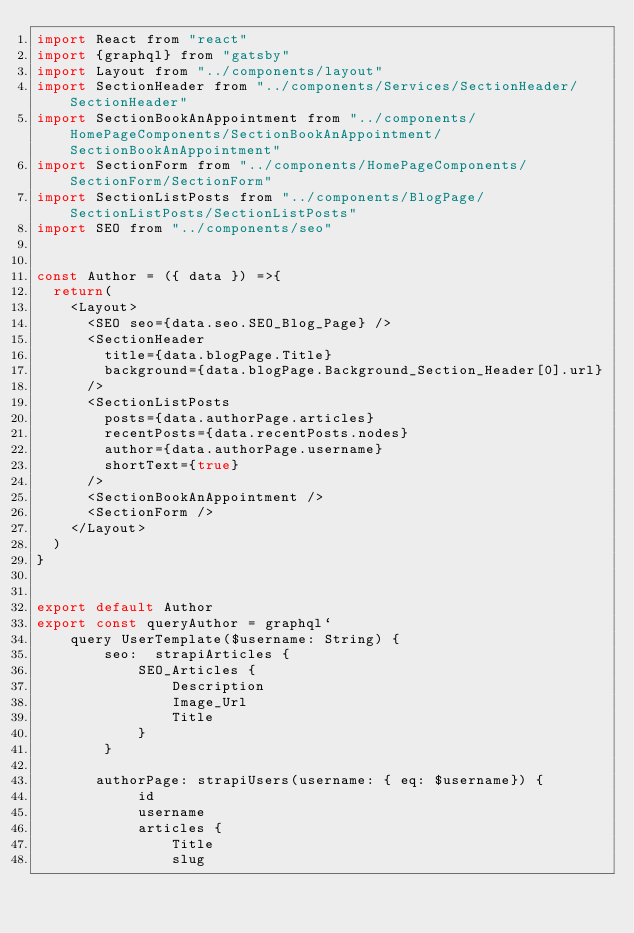<code> <loc_0><loc_0><loc_500><loc_500><_JavaScript_>import React from "react"
import {graphql} from "gatsby"
import Layout from "../components/layout"
import SectionHeader from "../components/Services/SectionHeader/SectionHeader"
import SectionBookAnAppointment from "../components/HomePageComponents/SectionBookAnAppointment/SectionBookAnAppointment"
import SectionForm from "../components/HomePageComponents/SectionForm/SectionForm"
import SectionListPosts from "../components/BlogPage/SectionListPosts/SectionListPosts"
import SEO from "../components/seo"


const Author = ({ data }) =>{
  return(
    <Layout>
      <SEO seo={data.seo.SEO_Blog_Page} />
      <SectionHeader
        title={data.blogPage.Title}
        background={data.blogPage.Background_Section_Header[0].url}
      />
      <SectionListPosts
        posts={data.authorPage.articles}
        recentPosts={data.recentPosts.nodes}
        author={data.authorPage.username}
        shortText={true}
      />
      <SectionBookAnAppointment />
      <SectionForm />
    </Layout>
  )
}


export default Author
export const queryAuthor = graphql`
    query UserTemplate($username: String) {
        seo:  strapiArticles {
            SEO_Articles {
                Description
                Image_Url
                Title
            }
        }
    
       authorPage: strapiUsers(username: { eq: $username}) {
            id
            username
            articles {
                Title
                slug</code> 